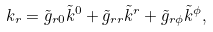Convert formula to latex. <formula><loc_0><loc_0><loc_500><loc_500>k _ { r } = \tilde { g } _ { r 0 } \tilde { k } ^ { 0 } + \tilde { g } _ { r r } \tilde { k } ^ { r } + \tilde { g } _ { r \phi } \tilde { k } ^ { \phi } ,</formula> 